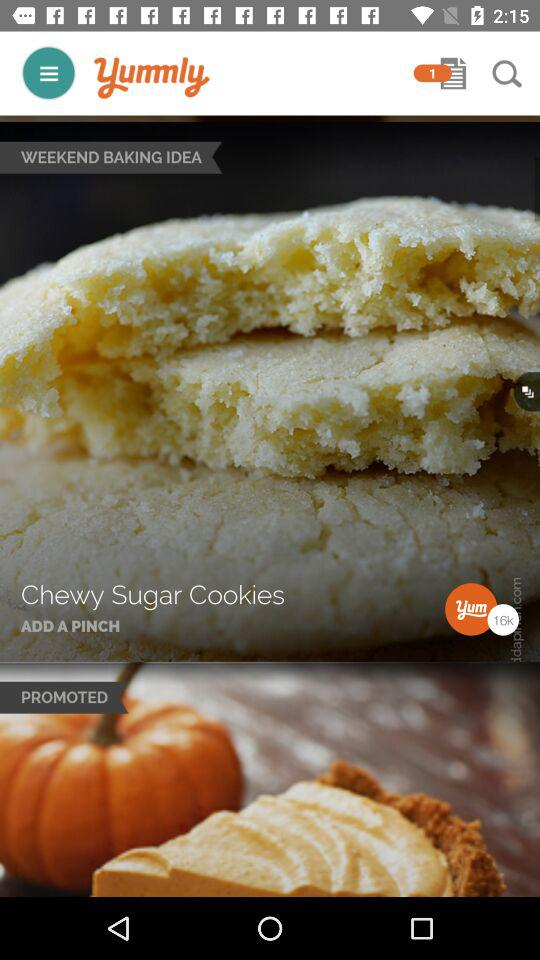What is the number of notifications? The number of notifications is 1. 